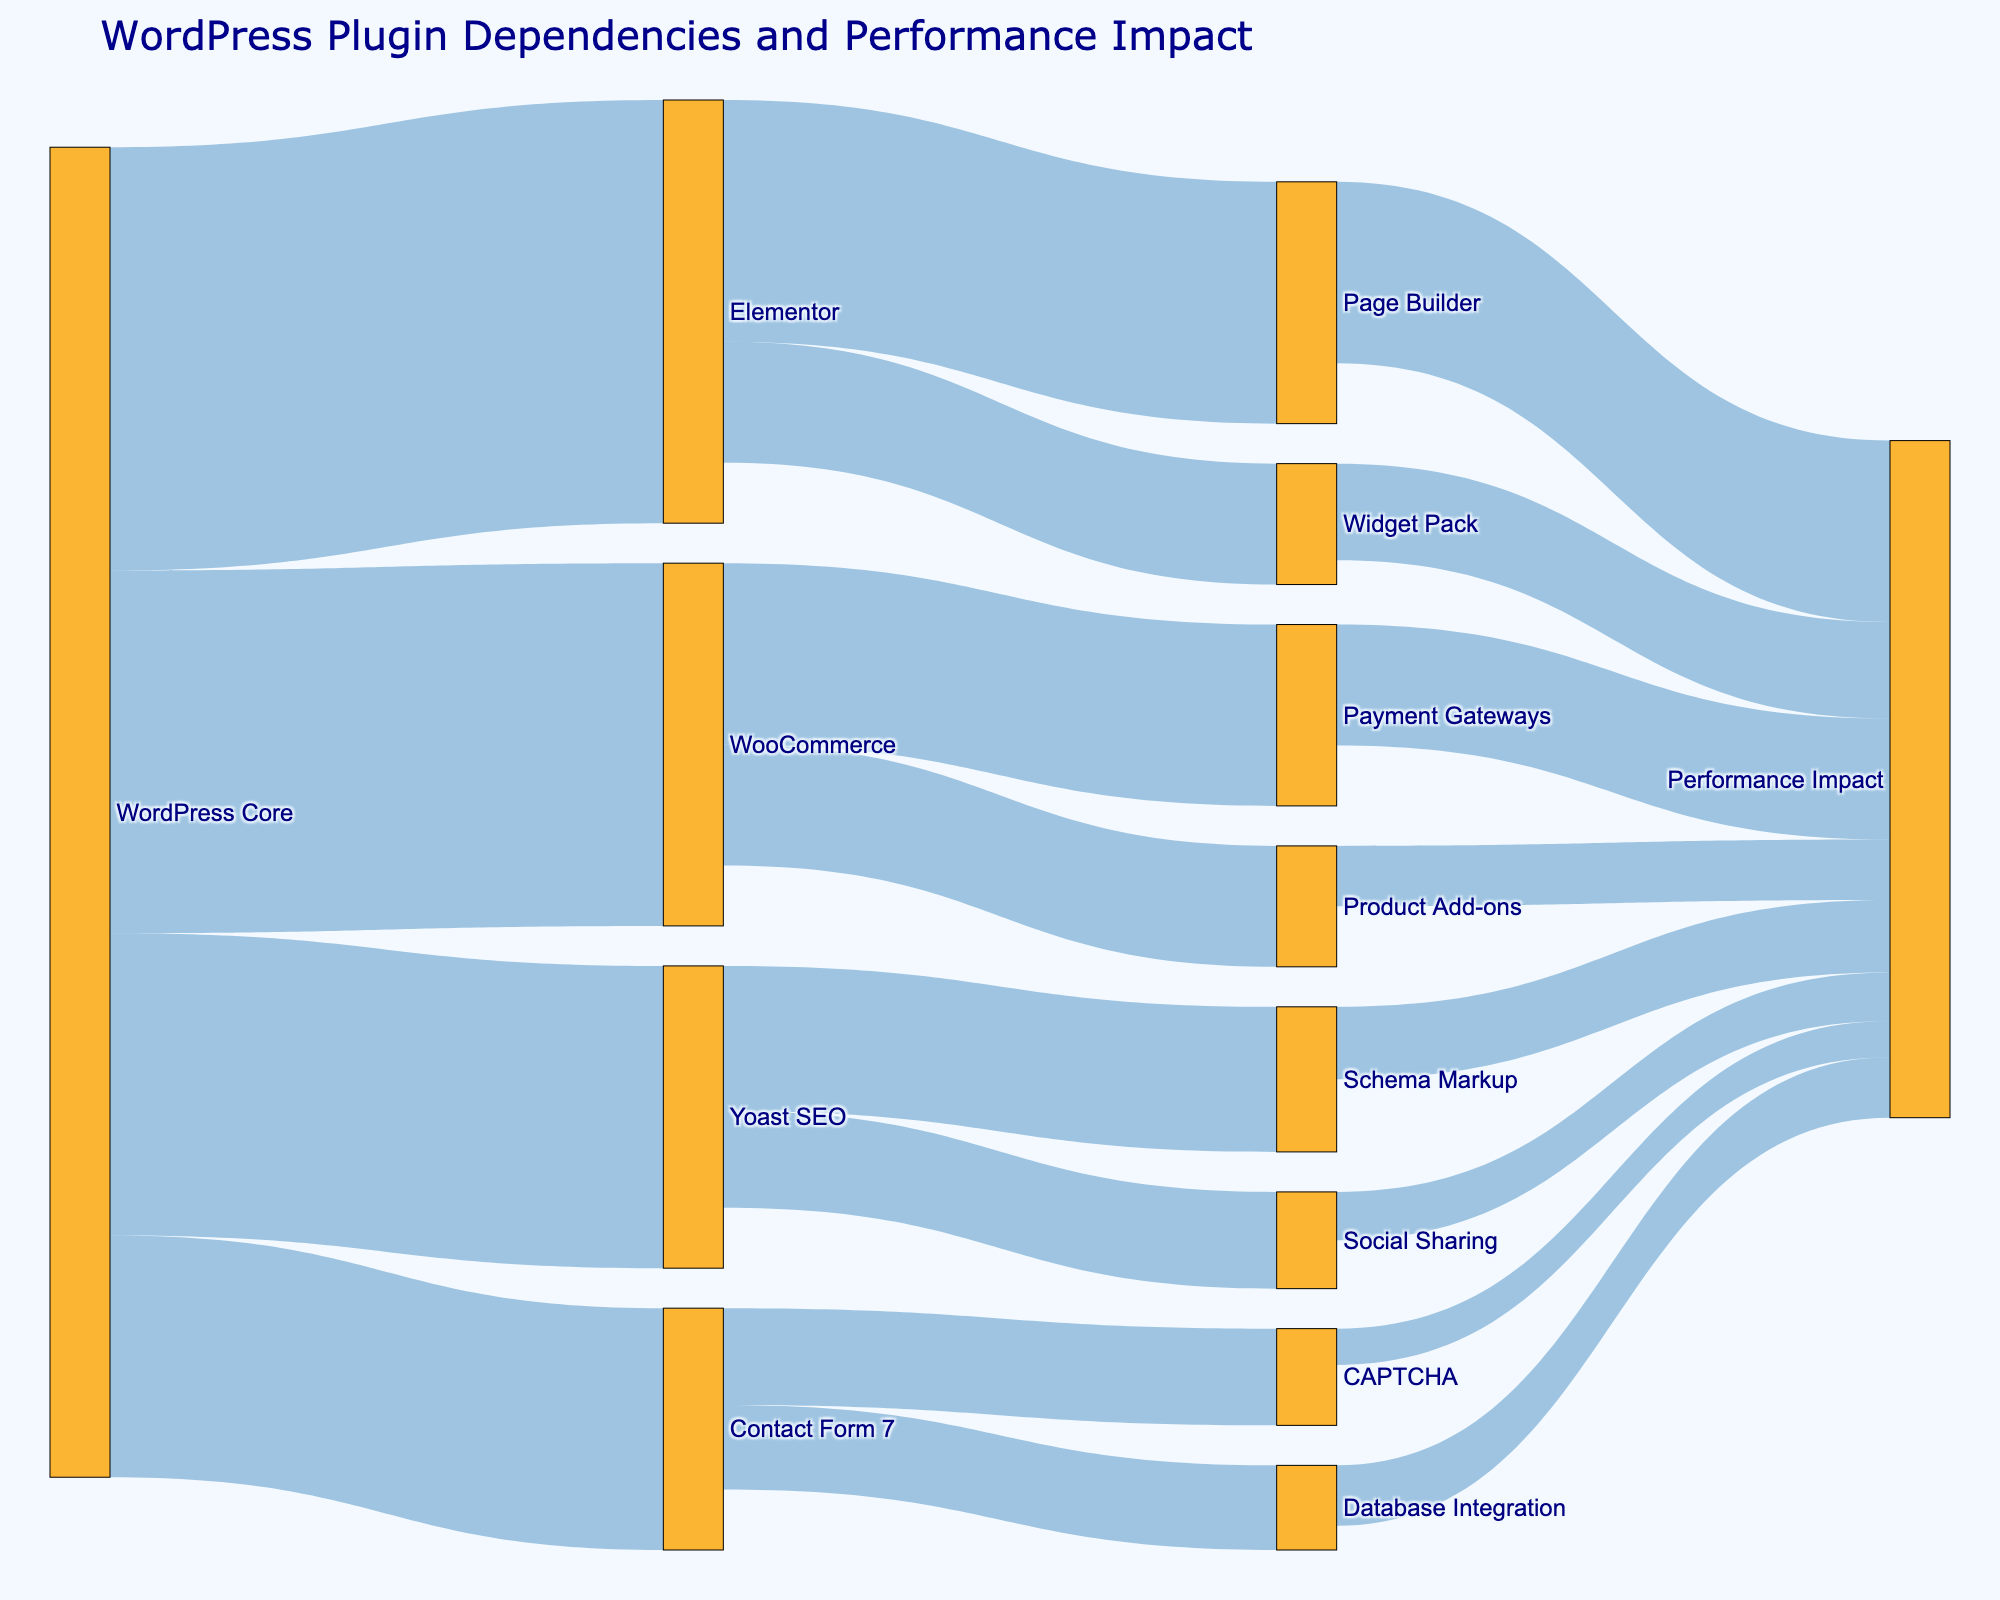What is the main objective of the Sankey Diagram? The main objective of the Sankey Diagram is to show the dependencies between WordPress plugins and their impact on site performance.
Answer: To show dependencies and performance impact Which plugin has the highest dependency on the WordPress Core? By examining the lines originating from "WordPress Core," Elementor has the highest dependency with a value of 35.
Answer: Elementor How many plugins depend directly on WooCommerce? Count the lines originating from "WooCommerce." There are two direct dependencies: Payment Gateways and Product Add-ons.
Answer: 2 Which dependency of Yoast SEO has a greater impact on performance, Schema Markup or Social Sharing? Compare the values of the lines from Yoast SEO to Schema Markup and Social Sharing. Schema Markup has a value of 6, while Social Sharing has a value of 4.
Answer: Schema Markup What's the total performance impact of the plugins that depend directly on Elementor? Add the values of the lines from Elementor’s dependencies (Page Builder: 15 and Widget Pack: 8), which gives us 15 + 8 = 23.
Answer: 23 How does the performance impact of Contact Form 7's CAPTCHA compare to its Database Integration? Compare the values of the lines from Contact Form 7 to CAPTCHA (3) and Database Integration (5). CAPTCHA has a lower impact.
Answer: CAPTCHA has a lower impact Which plugin contributes the least to the performance impact? Look for the smallest value associated with "Performance Impact." CAPTCHA from Contact Form 7 has the smallest value of 3.
Answer: CAPTCHA What's the combined performance impact of all plugins? Sum the performance impacts: 10 (Payment Gateways) + 5 (Product Add-ons) + 6 (Schema Markup) + 4 (Social Sharing) + 15 (Page Builder) + 8 (Widget Pack) + 3 (CAPTCHA) + 5 (Database Integration). The sum is 56.
Answer: 56 Which plugin's dependency chain contributes the most to the performance impact? Add up the performance impacts for each primary plugin: Elementor (Page Builder and Widget Pack): 15 + 8 = 23, WooCommerce (Payment Gateways and Product Add-ons): 10 + 5 = 15, Yoast SEO (Schema Markup and Social Sharing): 6 + 4 = 10, Contact Form 7 (CAPTCHA and Database Integration): 3 + 5 = 8. Elementor has the highest combined impact.
Answer: Elementor How many plugins are represented as nodes in the Sankey Diagram? Count all unique nodes listed in the figure. There are 12 unique plugins represented.
Answer: 12 